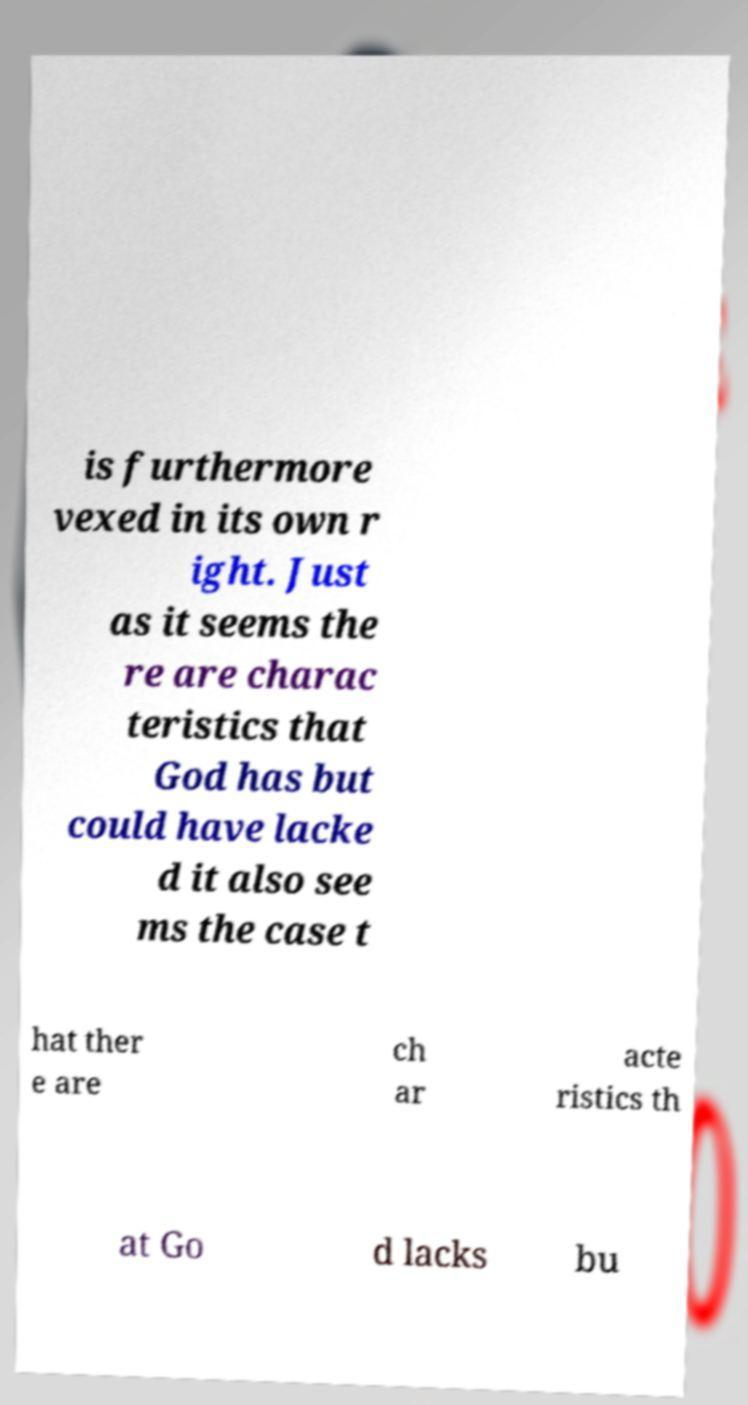Could you extract and type out the text from this image? is furthermore vexed in its own r ight. Just as it seems the re are charac teristics that God has but could have lacke d it also see ms the case t hat ther e are ch ar acte ristics th at Go d lacks bu 